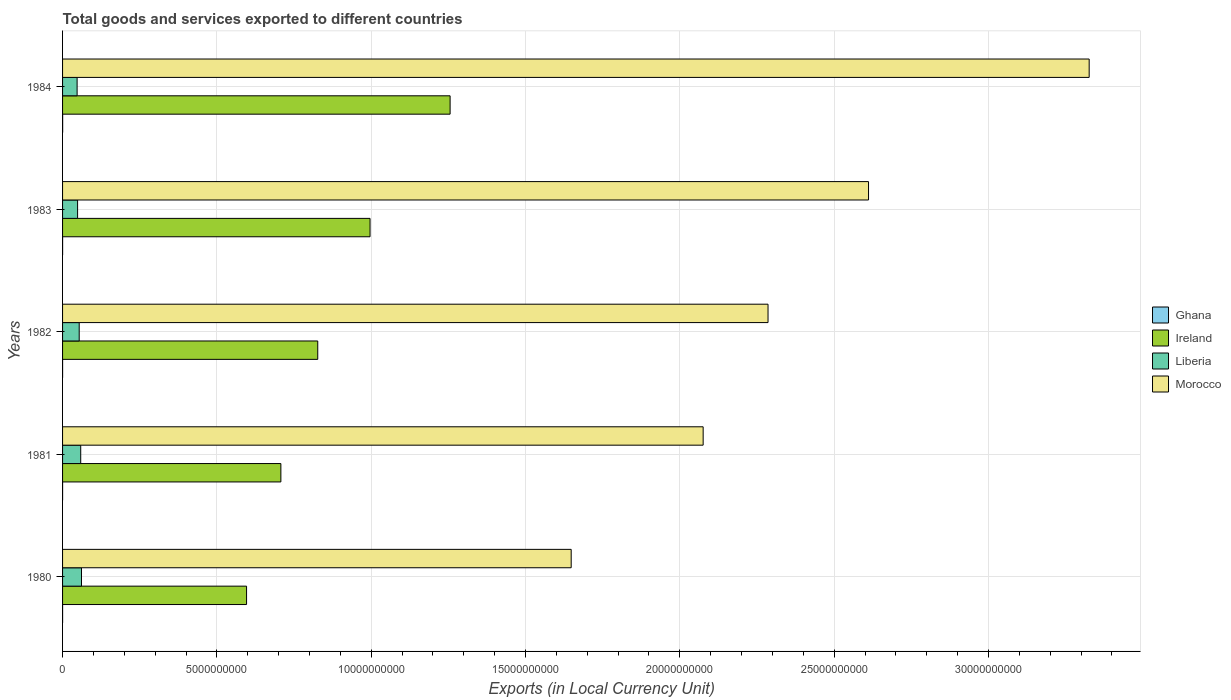How many groups of bars are there?
Keep it short and to the point. 5. Are the number of bars on each tick of the Y-axis equal?
Give a very brief answer. Yes. How many bars are there on the 4th tick from the top?
Offer a terse response. 4. How many bars are there on the 2nd tick from the bottom?
Provide a succinct answer. 4. What is the Amount of goods and services exports in Liberia in 1980?
Your answer should be very brief. 6.13e+08. Across all years, what is the maximum Amount of goods and services exports in Ireland?
Your response must be concise. 1.26e+1. Across all years, what is the minimum Amount of goods and services exports in Ghana?
Make the answer very short. 2.89e+05. What is the total Amount of goods and services exports in Ghana in the graph?
Offer a terse response. 4.20e+06. What is the difference between the Amount of goods and services exports in Ireland in 1980 and that in 1983?
Make the answer very short. -4.00e+09. What is the difference between the Amount of goods and services exports in Ireland in 1983 and the Amount of goods and services exports in Ghana in 1984?
Offer a terse response. 9.96e+09. What is the average Amount of goods and services exports in Ghana per year?
Give a very brief answer. 8.39e+05. In the year 1984, what is the difference between the Amount of goods and services exports in Ireland and Amount of goods and services exports in Ghana?
Keep it short and to the point. 1.26e+1. In how many years, is the Amount of goods and services exports in Morocco greater than 3000000000 LCU?
Keep it short and to the point. 5. What is the ratio of the Amount of goods and services exports in Morocco in 1980 to that in 1981?
Offer a very short reply. 0.79. Is the Amount of goods and services exports in Morocco in 1980 less than that in 1981?
Your answer should be very brief. Yes. Is the difference between the Amount of goods and services exports in Ireland in 1980 and 1984 greater than the difference between the Amount of goods and services exports in Ghana in 1980 and 1984?
Your answer should be compact. No. What is the difference between the highest and the second highest Amount of goods and services exports in Morocco?
Offer a terse response. 7.15e+09. What is the difference between the highest and the lowest Amount of goods and services exports in Ireland?
Offer a terse response. 6.59e+09. Is the sum of the Amount of goods and services exports in Liberia in 1981 and 1983 greater than the maximum Amount of goods and services exports in Morocco across all years?
Provide a short and direct response. No. What does the 1st bar from the top in 1984 represents?
Your answer should be very brief. Morocco. What does the 3rd bar from the bottom in 1980 represents?
Your answer should be very brief. Liberia. Is it the case that in every year, the sum of the Amount of goods and services exports in Ireland and Amount of goods and services exports in Ghana is greater than the Amount of goods and services exports in Liberia?
Provide a short and direct response. Yes. Are all the bars in the graph horizontal?
Your answer should be compact. Yes. Are the values on the major ticks of X-axis written in scientific E-notation?
Give a very brief answer. No. Where does the legend appear in the graph?
Give a very brief answer. Center right. How are the legend labels stacked?
Keep it short and to the point. Vertical. What is the title of the graph?
Your answer should be very brief. Total goods and services exported to different countries. Does "Pacific island small states" appear as one of the legend labels in the graph?
Offer a very short reply. No. What is the label or title of the X-axis?
Your response must be concise. Exports (in Local Currency Unit). What is the Exports (in Local Currency Unit) of Ghana in 1980?
Your answer should be very brief. 3.63e+05. What is the Exports (in Local Currency Unit) of Ireland in 1980?
Make the answer very short. 5.96e+09. What is the Exports (in Local Currency Unit) of Liberia in 1980?
Your answer should be compact. 6.13e+08. What is the Exports (in Local Currency Unit) of Morocco in 1980?
Your answer should be compact. 1.65e+1. What is the Exports (in Local Currency Unit) in Ghana in 1981?
Your response must be concise. 3.45e+05. What is the Exports (in Local Currency Unit) in Ireland in 1981?
Offer a terse response. 7.07e+09. What is the Exports (in Local Currency Unit) of Liberia in 1981?
Provide a short and direct response. 5.88e+08. What is the Exports (in Local Currency Unit) in Morocco in 1981?
Provide a succinct answer. 2.08e+1. What is the Exports (in Local Currency Unit) of Ghana in 1982?
Give a very brief answer. 2.89e+05. What is the Exports (in Local Currency Unit) in Ireland in 1982?
Provide a succinct answer. 8.27e+09. What is the Exports (in Local Currency Unit) in Liberia in 1982?
Your answer should be very brief. 5.39e+08. What is the Exports (in Local Currency Unit) of Morocco in 1982?
Keep it short and to the point. 2.29e+1. What is the Exports (in Local Currency Unit) of Ghana in 1983?
Provide a succinct answer. 1.02e+06. What is the Exports (in Local Currency Unit) of Ireland in 1983?
Make the answer very short. 9.96e+09. What is the Exports (in Local Currency Unit) of Liberia in 1983?
Your answer should be compact. 4.87e+08. What is the Exports (in Local Currency Unit) in Morocco in 1983?
Ensure brevity in your answer.  2.61e+1. What is the Exports (in Local Currency Unit) of Ghana in 1984?
Make the answer very short. 2.18e+06. What is the Exports (in Local Currency Unit) in Ireland in 1984?
Give a very brief answer. 1.26e+1. What is the Exports (in Local Currency Unit) of Liberia in 1984?
Offer a terse response. 4.71e+08. What is the Exports (in Local Currency Unit) in Morocco in 1984?
Keep it short and to the point. 3.33e+1. Across all years, what is the maximum Exports (in Local Currency Unit) in Ghana?
Offer a very short reply. 2.18e+06. Across all years, what is the maximum Exports (in Local Currency Unit) of Ireland?
Provide a succinct answer. 1.26e+1. Across all years, what is the maximum Exports (in Local Currency Unit) in Liberia?
Make the answer very short. 6.13e+08. Across all years, what is the maximum Exports (in Local Currency Unit) of Morocco?
Offer a very short reply. 3.33e+1. Across all years, what is the minimum Exports (in Local Currency Unit) in Ghana?
Offer a terse response. 2.89e+05. Across all years, what is the minimum Exports (in Local Currency Unit) in Ireland?
Your answer should be compact. 5.96e+09. Across all years, what is the minimum Exports (in Local Currency Unit) of Liberia?
Provide a short and direct response. 4.71e+08. Across all years, what is the minimum Exports (in Local Currency Unit) of Morocco?
Offer a very short reply. 1.65e+1. What is the total Exports (in Local Currency Unit) in Ghana in the graph?
Ensure brevity in your answer.  4.20e+06. What is the total Exports (in Local Currency Unit) in Ireland in the graph?
Offer a very short reply. 4.38e+1. What is the total Exports (in Local Currency Unit) in Liberia in the graph?
Make the answer very short. 2.70e+09. What is the total Exports (in Local Currency Unit) in Morocco in the graph?
Provide a short and direct response. 1.19e+11. What is the difference between the Exports (in Local Currency Unit) of Ghana in 1980 and that in 1981?
Keep it short and to the point. 1.74e+04. What is the difference between the Exports (in Local Currency Unit) in Ireland in 1980 and that in 1981?
Make the answer very short. -1.11e+09. What is the difference between the Exports (in Local Currency Unit) in Liberia in 1980 and that in 1981?
Your answer should be compact. 2.55e+07. What is the difference between the Exports (in Local Currency Unit) of Morocco in 1980 and that in 1981?
Provide a short and direct response. -4.28e+09. What is the difference between the Exports (in Local Currency Unit) of Ghana in 1980 and that in 1982?
Offer a very short reply. 7.42e+04. What is the difference between the Exports (in Local Currency Unit) in Ireland in 1980 and that in 1982?
Provide a succinct answer. -2.31e+09. What is the difference between the Exports (in Local Currency Unit) in Liberia in 1980 and that in 1982?
Make the answer very short. 7.45e+07. What is the difference between the Exports (in Local Currency Unit) of Morocco in 1980 and that in 1982?
Ensure brevity in your answer.  -6.38e+09. What is the difference between the Exports (in Local Currency Unit) of Ghana in 1980 and that in 1983?
Your answer should be compact. -6.60e+05. What is the difference between the Exports (in Local Currency Unit) of Ireland in 1980 and that in 1983?
Your answer should be very brief. -4.00e+09. What is the difference between the Exports (in Local Currency Unit) of Liberia in 1980 and that in 1983?
Your answer should be very brief. 1.26e+08. What is the difference between the Exports (in Local Currency Unit) of Morocco in 1980 and that in 1983?
Ensure brevity in your answer.  -9.63e+09. What is the difference between the Exports (in Local Currency Unit) of Ghana in 1980 and that in 1984?
Offer a terse response. -1.81e+06. What is the difference between the Exports (in Local Currency Unit) of Ireland in 1980 and that in 1984?
Your answer should be compact. -6.59e+09. What is the difference between the Exports (in Local Currency Unit) in Liberia in 1980 and that in 1984?
Your answer should be very brief. 1.42e+08. What is the difference between the Exports (in Local Currency Unit) in Morocco in 1980 and that in 1984?
Keep it short and to the point. -1.68e+1. What is the difference between the Exports (in Local Currency Unit) of Ghana in 1981 and that in 1982?
Provide a short and direct response. 5.68e+04. What is the difference between the Exports (in Local Currency Unit) of Ireland in 1981 and that in 1982?
Make the answer very short. -1.19e+09. What is the difference between the Exports (in Local Currency Unit) in Liberia in 1981 and that in 1982?
Provide a succinct answer. 4.90e+07. What is the difference between the Exports (in Local Currency Unit) of Morocco in 1981 and that in 1982?
Offer a very short reply. -2.10e+09. What is the difference between the Exports (in Local Currency Unit) in Ghana in 1981 and that in 1983?
Make the answer very short. -6.77e+05. What is the difference between the Exports (in Local Currency Unit) in Ireland in 1981 and that in 1983?
Keep it short and to the point. -2.89e+09. What is the difference between the Exports (in Local Currency Unit) of Liberia in 1981 and that in 1983?
Give a very brief answer. 1.01e+08. What is the difference between the Exports (in Local Currency Unit) of Morocco in 1981 and that in 1983?
Ensure brevity in your answer.  -5.36e+09. What is the difference between the Exports (in Local Currency Unit) of Ghana in 1981 and that in 1984?
Provide a short and direct response. -1.83e+06. What is the difference between the Exports (in Local Currency Unit) in Ireland in 1981 and that in 1984?
Your answer should be very brief. -5.48e+09. What is the difference between the Exports (in Local Currency Unit) of Liberia in 1981 and that in 1984?
Keep it short and to the point. 1.17e+08. What is the difference between the Exports (in Local Currency Unit) of Morocco in 1981 and that in 1984?
Your response must be concise. -1.25e+1. What is the difference between the Exports (in Local Currency Unit) in Ghana in 1982 and that in 1983?
Give a very brief answer. -7.34e+05. What is the difference between the Exports (in Local Currency Unit) of Ireland in 1982 and that in 1983?
Make the answer very short. -1.69e+09. What is the difference between the Exports (in Local Currency Unit) in Liberia in 1982 and that in 1983?
Offer a very short reply. 5.20e+07. What is the difference between the Exports (in Local Currency Unit) in Morocco in 1982 and that in 1983?
Your answer should be compact. -3.26e+09. What is the difference between the Exports (in Local Currency Unit) of Ghana in 1982 and that in 1984?
Offer a terse response. -1.89e+06. What is the difference between the Exports (in Local Currency Unit) in Ireland in 1982 and that in 1984?
Your answer should be compact. -4.29e+09. What is the difference between the Exports (in Local Currency Unit) of Liberia in 1982 and that in 1984?
Give a very brief answer. 6.80e+07. What is the difference between the Exports (in Local Currency Unit) of Morocco in 1982 and that in 1984?
Your answer should be very brief. -1.04e+1. What is the difference between the Exports (in Local Currency Unit) in Ghana in 1983 and that in 1984?
Make the answer very short. -1.15e+06. What is the difference between the Exports (in Local Currency Unit) of Ireland in 1983 and that in 1984?
Your answer should be compact. -2.59e+09. What is the difference between the Exports (in Local Currency Unit) in Liberia in 1983 and that in 1984?
Offer a very short reply. 1.60e+07. What is the difference between the Exports (in Local Currency Unit) of Morocco in 1983 and that in 1984?
Your answer should be compact. -7.15e+09. What is the difference between the Exports (in Local Currency Unit) of Ghana in 1980 and the Exports (in Local Currency Unit) of Ireland in 1981?
Offer a very short reply. -7.07e+09. What is the difference between the Exports (in Local Currency Unit) of Ghana in 1980 and the Exports (in Local Currency Unit) of Liberia in 1981?
Give a very brief answer. -5.88e+08. What is the difference between the Exports (in Local Currency Unit) of Ghana in 1980 and the Exports (in Local Currency Unit) of Morocco in 1981?
Offer a very short reply. -2.08e+1. What is the difference between the Exports (in Local Currency Unit) in Ireland in 1980 and the Exports (in Local Currency Unit) in Liberia in 1981?
Give a very brief answer. 5.37e+09. What is the difference between the Exports (in Local Currency Unit) in Ireland in 1980 and the Exports (in Local Currency Unit) in Morocco in 1981?
Provide a short and direct response. -1.48e+1. What is the difference between the Exports (in Local Currency Unit) in Liberia in 1980 and the Exports (in Local Currency Unit) in Morocco in 1981?
Your answer should be compact. -2.01e+1. What is the difference between the Exports (in Local Currency Unit) of Ghana in 1980 and the Exports (in Local Currency Unit) of Ireland in 1982?
Provide a short and direct response. -8.27e+09. What is the difference between the Exports (in Local Currency Unit) of Ghana in 1980 and the Exports (in Local Currency Unit) of Liberia in 1982?
Ensure brevity in your answer.  -5.39e+08. What is the difference between the Exports (in Local Currency Unit) of Ghana in 1980 and the Exports (in Local Currency Unit) of Morocco in 1982?
Offer a very short reply. -2.29e+1. What is the difference between the Exports (in Local Currency Unit) in Ireland in 1980 and the Exports (in Local Currency Unit) in Liberia in 1982?
Offer a very short reply. 5.42e+09. What is the difference between the Exports (in Local Currency Unit) of Ireland in 1980 and the Exports (in Local Currency Unit) of Morocco in 1982?
Keep it short and to the point. -1.69e+1. What is the difference between the Exports (in Local Currency Unit) of Liberia in 1980 and the Exports (in Local Currency Unit) of Morocco in 1982?
Your response must be concise. -2.22e+1. What is the difference between the Exports (in Local Currency Unit) in Ghana in 1980 and the Exports (in Local Currency Unit) in Ireland in 1983?
Ensure brevity in your answer.  -9.96e+09. What is the difference between the Exports (in Local Currency Unit) in Ghana in 1980 and the Exports (in Local Currency Unit) in Liberia in 1983?
Give a very brief answer. -4.87e+08. What is the difference between the Exports (in Local Currency Unit) of Ghana in 1980 and the Exports (in Local Currency Unit) of Morocco in 1983?
Offer a terse response. -2.61e+1. What is the difference between the Exports (in Local Currency Unit) of Ireland in 1980 and the Exports (in Local Currency Unit) of Liberia in 1983?
Give a very brief answer. 5.47e+09. What is the difference between the Exports (in Local Currency Unit) of Ireland in 1980 and the Exports (in Local Currency Unit) of Morocco in 1983?
Ensure brevity in your answer.  -2.02e+1. What is the difference between the Exports (in Local Currency Unit) in Liberia in 1980 and the Exports (in Local Currency Unit) in Morocco in 1983?
Give a very brief answer. -2.55e+1. What is the difference between the Exports (in Local Currency Unit) of Ghana in 1980 and the Exports (in Local Currency Unit) of Ireland in 1984?
Ensure brevity in your answer.  -1.26e+1. What is the difference between the Exports (in Local Currency Unit) of Ghana in 1980 and the Exports (in Local Currency Unit) of Liberia in 1984?
Your answer should be very brief. -4.71e+08. What is the difference between the Exports (in Local Currency Unit) of Ghana in 1980 and the Exports (in Local Currency Unit) of Morocco in 1984?
Your answer should be very brief. -3.33e+1. What is the difference between the Exports (in Local Currency Unit) of Ireland in 1980 and the Exports (in Local Currency Unit) of Liberia in 1984?
Keep it short and to the point. 5.49e+09. What is the difference between the Exports (in Local Currency Unit) in Ireland in 1980 and the Exports (in Local Currency Unit) in Morocco in 1984?
Provide a succinct answer. -2.73e+1. What is the difference between the Exports (in Local Currency Unit) in Liberia in 1980 and the Exports (in Local Currency Unit) in Morocco in 1984?
Offer a terse response. -3.26e+1. What is the difference between the Exports (in Local Currency Unit) of Ghana in 1981 and the Exports (in Local Currency Unit) of Ireland in 1982?
Provide a succinct answer. -8.27e+09. What is the difference between the Exports (in Local Currency Unit) of Ghana in 1981 and the Exports (in Local Currency Unit) of Liberia in 1982?
Your response must be concise. -5.39e+08. What is the difference between the Exports (in Local Currency Unit) of Ghana in 1981 and the Exports (in Local Currency Unit) of Morocco in 1982?
Make the answer very short. -2.29e+1. What is the difference between the Exports (in Local Currency Unit) of Ireland in 1981 and the Exports (in Local Currency Unit) of Liberia in 1982?
Provide a succinct answer. 6.53e+09. What is the difference between the Exports (in Local Currency Unit) in Ireland in 1981 and the Exports (in Local Currency Unit) in Morocco in 1982?
Keep it short and to the point. -1.58e+1. What is the difference between the Exports (in Local Currency Unit) in Liberia in 1981 and the Exports (in Local Currency Unit) in Morocco in 1982?
Make the answer very short. -2.23e+1. What is the difference between the Exports (in Local Currency Unit) of Ghana in 1981 and the Exports (in Local Currency Unit) of Ireland in 1983?
Make the answer very short. -9.96e+09. What is the difference between the Exports (in Local Currency Unit) in Ghana in 1981 and the Exports (in Local Currency Unit) in Liberia in 1983?
Provide a short and direct response. -4.87e+08. What is the difference between the Exports (in Local Currency Unit) of Ghana in 1981 and the Exports (in Local Currency Unit) of Morocco in 1983?
Provide a short and direct response. -2.61e+1. What is the difference between the Exports (in Local Currency Unit) of Ireland in 1981 and the Exports (in Local Currency Unit) of Liberia in 1983?
Offer a terse response. 6.59e+09. What is the difference between the Exports (in Local Currency Unit) in Ireland in 1981 and the Exports (in Local Currency Unit) in Morocco in 1983?
Offer a very short reply. -1.90e+1. What is the difference between the Exports (in Local Currency Unit) of Liberia in 1981 and the Exports (in Local Currency Unit) of Morocco in 1983?
Provide a short and direct response. -2.55e+1. What is the difference between the Exports (in Local Currency Unit) of Ghana in 1981 and the Exports (in Local Currency Unit) of Ireland in 1984?
Your response must be concise. -1.26e+1. What is the difference between the Exports (in Local Currency Unit) of Ghana in 1981 and the Exports (in Local Currency Unit) of Liberia in 1984?
Offer a very short reply. -4.71e+08. What is the difference between the Exports (in Local Currency Unit) of Ghana in 1981 and the Exports (in Local Currency Unit) of Morocco in 1984?
Offer a very short reply. -3.33e+1. What is the difference between the Exports (in Local Currency Unit) of Ireland in 1981 and the Exports (in Local Currency Unit) of Liberia in 1984?
Ensure brevity in your answer.  6.60e+09. What is the difference between the Exports (in Local Currency Unit) in Ireland in 1981 and the Exports (in Local Currency Unit) in Morocco in 1984?
Provide a succinct answer. -2.62e+1. What is the difference between the Exports (in Local Currency Unit) of Liberia in 1981 and the Exports (in Local Currency Unit) of Morocco in 1984?
Offer a terse response. -3.27e+1. What is the difference between the Exports (in Local Currency Unit) of Ghana in 1982 and the Exports (in Local Currency Unit) of Ireland in 1983?
Your response must be concise. -9.96e+09. What is the difference between the Exports (in Local Currency Unit) in Ghana in 1982 and the Exports (in Local Currency Unit) in Liberia in 1983?
Provide a succinct answer. -4.87e+08. What is the difference between the Exports (in Local Currency Unit) of Ghana in 1982 and the Exports (in Local Currency Unit) of Morocco in 1983?
Provide a succinct answer. -2.61e+1. What is the difference between the Exports (in Local Currency Unit) in Ireland in 1982 and the Exports (in Local Currency Unit) in Liberia in 1983?
Offer a very short reply. 7.78e+09. What is the difference between the Exports (in Local Currency Unit) of Ireland in 1982 and the Exports (in Local Currency Unit) of Morocco in 1983?
Your answer should be very brief. -1.78e+1. What is the difference between the Exports (in Local Currency Unit) of Liberia in 1982 and the Exports (in Local Currency Unit) of Morocco in 1983?
Ensure brevity in your answer.  -2.56e+1. What is the difference between the Exports (in Local Currency Unit) of Ghana in 1982 and the Exports (in Local Currency Unit) of Ireland in 1984?
Offer a terse response. -1.26e+1. What is the difference between the Exports (in Local Currency Unit) of Ghana in 1982 and the Exports (in Local Currency Unit) of Liberia in 1984?
Give a very brief answer. -4.71e+08. What is the difference between the Exports (in Local Currency Unit) in Ghana in 1982 and the Exports (in Local Currency Unit) in Morocco in 1984?
Your answer should be very brief. -3.33e+1. What is the difference between the Exports (in Local Currency Unit) of Ireland in 1982 and the Exports (in Local Currency Unit) of Liberia in 1984?
Your response must be concise. 7.80e+09. What is the difference between the Exports (in Local Currency Unit) of Ireland in 1982 and the Exports (in Local Currency Unit) of Morocco in 1984?
Offer a very short reply. -2.50e+1. What is the difference between the Exports (in Local Currency Unit) in Liberia in 1982 and the Exports (in Local Currency Unit) in Morocco in 1984?
Provide a succinct answer. -3.27e+1. What is the difference between the Exports (in Local Currency Unit) in Ghana in 1983 and the Exports (in Local Currency Unit) in Ireland in 1984?
Your answer should be compact. -1.26e+1. What is the difference between the Exports (in Local Currency Unit) of Ghana in 1983 and the Exports (in Local Currency Unit) of Liberia in 1984?
Keep it short and to the point. -4.70e+08. What is the difference between the Exports (in Local Currency Unit) of Ghana in 1983 and the Exports (in Local Currency Unit) of Morocco in 1984?
Provide a short and direct response. -3.33e+1. What is the difference between the Exports (in Local Currency Unit) of Ireland in 1983 and the Exports (in Local Currency Unit) of Liberia in 1984?
Provide a short and direct response. 9.49e+09. What is the difference between the Exports (in Local Currency Unit) of Ireland in 1983 and the Exports (in Local Currency Unit) of Morocco in 1984?
Ensure brevity in your answer.  -2.33e+1. What is the difference between the Exports (in Local Currency Unit) of Liberia in 1983 and the Exports (in Local Currency Unit) of Morocco in 1984?
Your answer should be compact. -3.28e+1. What is the average Exports (in Local Currency Unit) of Ghana per year?
Make the answer very short. 8.39e+05. What is the average Exports (in Local Currency Unit) in Ireland per year?
Your answer should be compact. 8.76e+09. What is the average Exports (in Local Currency Unit) of Liberia per year?
Your response must be concise. 5.40e+08. What is the average Exports (in Local Currency Unit) of Morocco per year?
Provide a succinct answer. 2.39e+1. In the year 1980, what is the difference between the Exports (in Local Currency Unit) in Ghana and Exports (in Local Currency Unit) in Ireland?
Your answer should be compact. -5.96e+09. In the year 1980, what is the difference between the Exports (in Local Currency Unit) of Ghana and Exports (in Local Currency Unit) of Liberia?
Keep it short and to the point. -6.13e+08. In the year 1980, what is the difference between the Exports (in Local Currency Unit) in Ghana and Exports (in Local Currency Unit) in Morocco?
Your response must be concise. -1.65e+1. In the year 1980, what is the difference between the Exports (in Local Currency Unit) of Ireland and Exports (in Local Currency Unit) of Liberia?
Keep it short and to the point. 5.35e+09. In the year 1980, what is the difference between the Exports (in Local Currency Unit) in Ireland and Exports (in Local Currency Unit) in Morocco?
Your answer should be compact. -1.05e+1. In the year 1980, what is the difference between the Exports (in Local Currency Unit) of Liberia and Exports (in Local Currency Unit) of Morocco?
Provide a short and direct response. -1.59e+1. In the year 1981, what is the difference between the Exports (in Local Currency Unit) in Ghana and Exports (in Local Currency Unit) in Ireland?
Offer a very short reply. -7.07e+09. In the year 1981, what is the difference between the Exports (in Local Currency Unit) in Ghana and Exports (in Local Currency Unit) in Liberia?
Offer a terse response. -5.88e+08. In the year 1981, what is the difference between the Exports (in Local Currency Unit) of Ghana and Exports (in Local Currency Unit) of Morocco?
Your answer should be compact. -2.08e+1. In the year 1981, what is the difference between the Exports (in Local Currency Unit) of Ireland and Exports (in Local Currency Unit) of Liberia?
Your response must be concise. 6.49e+09. In the year 1981, what is the difference between the Exports (in Local Currency Unit) of Ireland and Exports (in Local Currency Unit) of Morocco?
Provide a succinct answer. -1.37e+1. In the year 1981, what is the difference between the Exports (in Local Currency Unit) in Liberia and Exports (in Local Currency Unit) in Morocco?
Provide a short and direct response. -2.02e+1. In the year 1982, what is the difference between the Exports (in Local Currency Unit) in Ghana and Exports (in Local Currency Unit) in Ireland?
Give a very brief answer. -8.27e+09. In the year 1982, what is the difference between the Exports (in Local Currency Unit) in Ghana and Exports (in Local Currency Unit) in Liberia?
Your answer should be compact. -5.39e+08. In the year 1982, what is the difference between the Exports (in Local Currency Unit) in Ghana and Exports (in Local Currency Unit) in Morocco?
Your answer should be very brief. -2.29e+1. In the year 1982, what is the difference between the Exports (in Local Currency Unit) in Ireland and Exports (in Local Currency Unit) in Liberia?
Provide a succinct answer. 7.73e+09. In the year 1982, what is the difference between the Exports (in Local Currency Unit) in Ireland and Exports (in Local Currency Unit) in Morocco?
Offer a very short reply. -1.46e+1. In the year 1982, what is the difference between the Exports (in Local Currency Unit) of Liberia and Exports (in Local Currency Unit) of Morocco?
Your response must be concise. -2.23e+1. In the year 1983, what is the difference between the Exports (in Local Currency Unit) in Ghana and Exports (in Local Currency Unit) in Ireland?
Keep it short and to the point. -9.96e+09. In the year 1983, what is the difference between the Exports (in Local Currency Unit) in Ghana and Exports (in Local Currency Unit) in Liberia?
Give a very brief answer. -4.86e+08. In the year 1983, what is the difference between the Exports (in Local Currency Unit) in Ghana and Exports (in Local Currency Unit) in Morocco?
Make the answer very short. -2.61e+1. In the year 1983, what is the difference between the Exports (in Local Currency Unit) of Ireland and Exports (in Local Currency Unit) of Liberia?
Provide a short and direct response. 9.48e+09. In the year 1983, what is the difference between the Exports (in Local Currency Unit) in Ireland and Exports (in Local Currency Unit) in Morocco?
Keep it short and to the point. -1.62e+1. In the year 1983, what is the difference between the Exports (in Local Currency Unit) of Liberia and Exports (in Local Currency Unit) of Morocco?
Give a very brief answer. -2.56e+1. In the year 1984, what is the difference between the Exports (in Local Currency Unit) in Ghana and Exports (in Local Currency Unit) in Ireland?
Your answer should be compact. -1.26e+1. In the year 1984, what is the difference between the Exports (in Local Currency Unit) of Ghana and Exports (in Local Currency Unit) of Liberia?
Ensure brevity in your answer.  -4.69e+08. In the year 1984, what is the difference between the Exports (in Local Currency Unit) in Ghana and Exports (in Local Currency Unit) in Morocco?
Offer a very short reply. -3.33e+1. In the year 1984, what is the difference between the Exports (in Local Currency Unit) in Ireland and Exports (in Local Currency Unit) in Liberia?
Your answer should be compact. 1.21e+1. In the year 1984, what is the difference between the Exports (in Local Currency Unit) of Ireland and Exports (in Local Currency Unit) of Morocco?
Ensure brevity in your answer.  -2.07e+1. In the year 1984, what is the difference between the Exports (in Local Currency Unit) of Liberia and Exports (in Local Currency Unit) of Morocco?
Your answer should be compact. -3.28e+1. What is the ratio of the Exports (in Local Currency Unit) of Ghana in 1980 to that in 1981?
Keep it short and to the point. 1.05. What is the ratio of the Exports (in Local Currency Unit) of Ireland in 1980 to that in 1981?
Provide a succinct answer. 0.84. What is the ratio of the Exports (in Local Currency Unit) in Liberia in 1980 to that in 1981?
Your response must be concise. 1.04. What is the ratio of the Exports (in Local Currency Unit) in Morocco in 1980 to that in 1981?
Provide a short and direct response. 0.79. What is the ratio of the Exports (in Local Currency Unit) in Ghana in 1980 to that in 1982?
Give a very brief answer. 1.26. What is the ratio of the Exports (in Local Currency Unit) in Ireland in 1980 to that in 1982?
Ensure brevity in your answer.  0.72. What is the ratio of the Exports (in Local Currency Unit) of Liberia in 1980 to that in 1982?
Offer a very short reply. 1.14. What is the ratio of the Exports (in Local Currency Unit) in Morocco in 1980 to that in 1982?
Keep it short and to the point. 0.72. What is the ratio of the Exports (in Local Currency Unit) of Ghana in 1980 to that in 1983?
Keep it short and to the point. 0.35. What is the ratio of the Exports (in Local Currency Unit) in Ireland in 1980 to that in 1983?
Your answer should be compact. 0.6. What is the ratio of the Exports (in Local Currency Unit) in Liberia in 1980 to that in 1983?
Give a very brief answer. 1.26. What is the ratio of the Exports (in Local Currency Unit) of Morocco in 1980 to that in 1983?
Give a very brief answer. 0.63. What is the ratio of the Exports (in Local Currency Unit) in Ghana in 1980 to that in 1984?
Your response must be concise. 0.17. What is the ratio of the Exports (in Local Currency Unit) of Ireland in 1980 to that in 1984?
Your response must be concise. 0.47. What is the ratio of the Exports (in Local Currency Unit) of Liberia in 1980 to that in 1984?
Your answer should be compact. 1.3. What is the ratio of the Exports (in Local Currency Unit) in Morocco in 1980 to that in 1984?
Offer a terse response. 0.5. What is the ratio of the Exports (in Local Currency Unit) of Ghana in 1981 to that in 1982?
Offer a terse response. 1.2. What is the ratio of the Exports (in Local Currency Unit) of Ireland in 1981 to that in 1982?
Keep it short and to the point. 0.86. What is the ratio of the Exports (in Local Currency Unit) of Liberia in 1981 to that in 1982?
Give a very brief answer. 1.09. What is the ratio of the Exports (in Local Currency Unit) of Morocco in 1981 to that in 1982?
Make the answer very short. 0.91. What is the ratio of the Exports (in Local Currency Unit) of Ghana in 1981 to that in 1983?
Keep it short and to the point. 0.34. What is the ratio of the Exports (in Local Currency Unit) of Ireland in 1981 to that in 1983?
Keep it short and to the point. 0.71. What is the ratio of the Exports (in Local Currency Unit) in Liberia in 1981 to that in 1983?
Give a very brief answer. 1.21. What is the ratio of the Exports (in Local Currency Unit) in Morocco in 1981 to that in 1983?
Give a very brief answer. 0.79. What is the ratio of the Exports (in Local Currency Unit) in Ghana in 1981 to that in 1984?
Provide a short and direct response. 0.16. What is the ratio of the Exports (in Local Currency Unit) of Ireland in 1981 to that in 1984?
Ensure brevity in your answer.  0.56. What is the ratio of the Exports (in Local Currency Unit) in Liberia in 1981 to that in 1984?
Your answer should be very brief. 1.25. What is the ratio of the Exports (in Local Currency Unit) of Morocco in 1981 to that in 1984?
Your answer should be compact. 0.62. What is the ratio of the Exports (in Local Currency Unit) of Ghana in 1982 to that in 1983?
Your response must be concise. 0.28. What is the ratio of the Exports (in Local Currency Unit) in Ireland in 1982 to that in 1983?
Offer a terse response. 0.83. What is the ratio of the Exports (in Local Currency Unit) in Liberia in 1982 to that in 1983?
Provide a succinct answer. 1.11. What is the ratio of the Exports (in Local Currency Unit) in Morocco in 1982 to that in 1983?
Provide a succinct answer. 0.88. What is the ratio of the Exports (in Local Currency Unit) of Ghana in 1982 to that in 1984?
Offer a terse response. 0.13. What is the ratio of the Exports (in Local Currency Unit) in Ireland in 1982 to that in 1984?
Provide a succinct answer. 0.66. What is the ratio of the Exports (in Local Currency Unit) of Liberia in 1982 to that in 1984?
Ensure brevity in your answer.  1.14. What is the ratio of the Exports (in Local Currency Unit) in Morocco in 1982 to that in 1984?
Provide a short and direct response. 0.69. What is the ratio of the Exports (in Local Currency Unit) of Ghana in 1983 to that in 1984?
Provide a short and direct response. 0.47. What is the ratio of the Exports (in Local Currency Unit) in Ireland in 1983 to that in 1984?
Your response must be concise. 0.79. What is the ratio of the Exports (in Local Currency Unit) of Liberia in 1983 to that in 1984?
Your response must be concise. 1.03. What is the ratio of the Exports (in Local Currency Unit) of Morocco in 1983 to that in 1984?
Offer a very short reply. 0.79. What is the difference between the highest and the second highest Exports (in Local Currency Unit) in Ghana?
Offer a very short reply. 1.15e+06. What is the difference between the highest and the second highest Exports (in Local Currency Unit) of Ireland?
Offer a very short reply. 2.59e+09. What is the difference between the highest and the second highest Exports (in Local Currency Unit) of Liberia?
Your answer should be compact. 2.55e+07. What is the difference between the highest and the second highest Exports (in Local Currency Unit) in Morocco?
Provide a succinct answer. 7.15e+09. What is the difference between the highest and the lowest Exports (in Local Currency Unit) in Ghana?
Offer a very short reply. 1.89e+06. What is the difference between the highest and the lowest Exports (in Local Currency Unit) in Ireland?
Provide a succinct answer. 6.59e+09. What is the difference between the highest and the lowest Exports (in Local Currency Unit) in Liberia?
Offer a terse response. 1.42e+08. What is the difference between the highest and the lowest Exports (in Local Currency Unit) in Morocco?
Offer a terse response. 1.68e+1. 